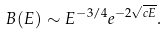Convert formula to latex. <formula><loc_0><loc_0><loc_500><loc_500>B ( E ) \sim E ^ { - 3 / 4 } e ^ { - 2 \sqrt { c E } } .</formula> 